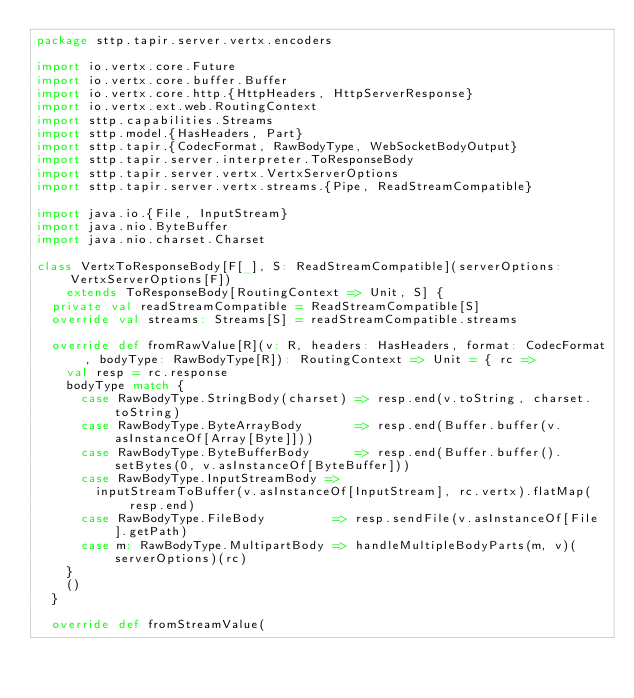Convert code to text. <code><loc_0><loc_0><loc_500><loc_500><_Scala_>package sttp.tapir.server.vertx.encoders

import io.vertx.core.Future
import io.vertx.core.buffer.Buffer
import io.vertx.core.http.{HttpHeaders, HttpServerResponse}
import io.vertx.ext.web.RoutingContext
import sttp.capabilities.Streams
import sttp.model.{HasHeaders, Part}
import sttp.tapir.{CodecFormat, RawBodyType, WebSocketBodyOutput}
import sttp.tapir.server.interpreter.ToResponseBody
import sttp.tapir.server.vertx.VertxServerOptions
import sttp.tapir.server.vertx.streams.{Pipe, ReadStreamCompatible}

import java.io.{File, InputStream}
import java.nio.ByteBuffer
import java.nio.charset.Charset

class VertxToResponseBody[F[_], S: ReadStreamCompatible](serverOptions: VertxServerOptions[F])
    extends ToResponseBody[RoutingContext => Unit, S] {
  private val readStreamCompatible = ReadStreamCompatible[S]
  override val streams: Streams[S] = readStreamCompatible.streams

  override def fromRawValue[R](v: R, headers: HasHeaders, format: CodecFormat, bodyType: RawBodyType[R]): RoutingContext => Unit = { rc =>
    val resp = rc.response
    bodyType match {
      case RawBodyType.StringBody(charset) => resp.end(v.toString, charset.toString)
      case RawBodyType.ByteArrayBody       => resp.end(Buffer.buffer(v.asInstanceOf[Array[Byte]]))
      case RawBodyType.ByteBufferBody      => resp.end(Buffer.buffer().setBytes(0, v.asInstanceOf[ByteBuffer]))
      case RawBodyType.InputStreamBody =>
        inputStreamToBuffer(v.asInstanceOf[InputStream], rc.vertx).flatMap(resp.end)
      case RawBodyType.FileBody         => resp.sendFile(v.asInstanceOf[File].getPath)
      case m: RawBodyType.MultipartBody => handleMultipleBodyParts(m, v)(serverOptions)(rc)
    }
    ()
  }

  override def fromStreamValue(</code> 